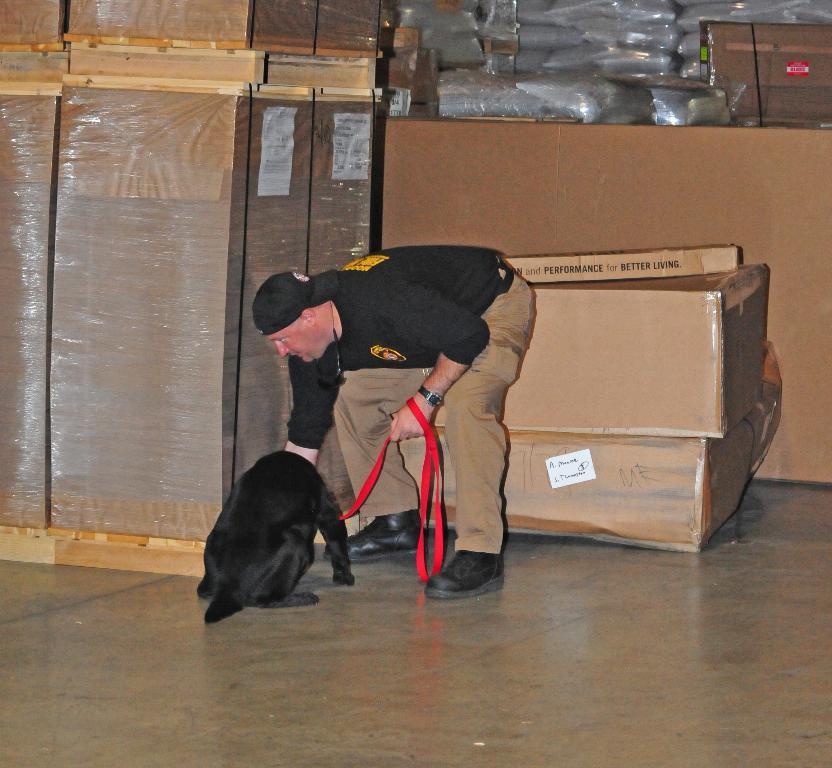Could you give a brief overview of what you see in this image? In this image I can see a person wearing black and brown colored dress is standing and holding a red colored belt in his hand which is tied to the dog which is black in color. In the background I ca see few cardboard boxes which are brown in color, few plastic covers and few wooden boxes. 